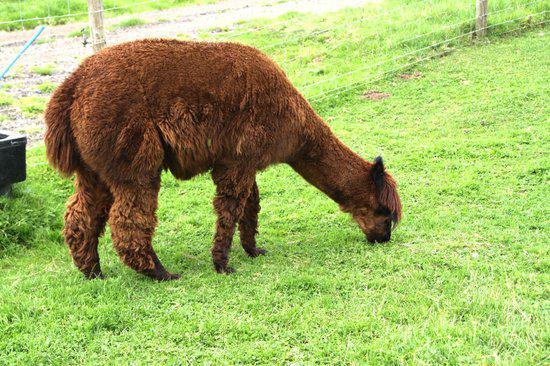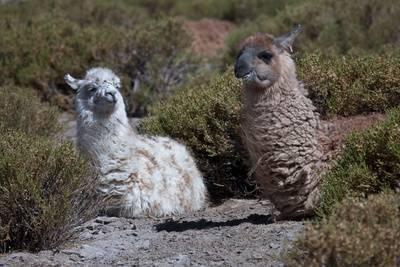The first image is the image on the left, the second image is the image on the right. Analyze the images presented: Is the assertion "The right image contains one llama reclining with its body aimed leftward and its pright head turned forward." valid? Answer yes or no. No. The first image is the image on the left, the second image is the image on the right. Assess this claim about the two images: "The left and right image contains no more than three total llamas.". Correct or not? Answer yes or no. Yes. 